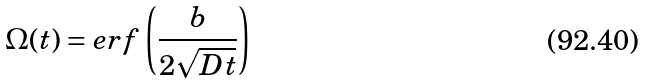Convert formula to latex. <formula><loc_0><loc_0><loc_500><loc_500>\Omega ( t ) = e r f \left ( \frac { b } { 2 \sqrt { D t } } \right )</formula> 